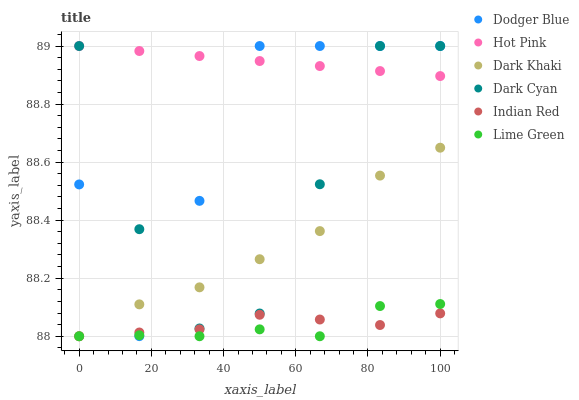Does Lime Green have the minimum area under the curve?
Answer yes or no. Yes. Does Hot Pink have the maximum area under the curve?
Answer yes or no. Yes. Does Dark Khaki have the minimum area under the curve?
Answer yes or no. No. Does Dark Khaki have the maximum area under the curve?
Answer yes or no. No. Is Hot Pink the smoothest?
Answer yes or no. Yes. Is Dodger Blue the roughest?
Answer yes or no. Yes. Is Dark Khaki the smoothest?
Answer yes or no. No. Is Dark Khaki the roughest?
Answer yes or no. No. Does Dark Khaki have the lowest value?
Answer yes or no. Yes. Does Dodger Blue have the lowest value?
Answer yes or no. No. Does Dark Cyan have the highest value?
Answer yes or no. Yes. Does Dark Khaki have the highest value?
Answer yes or no. No. Is Dark Khaki less than Hot Pink?
Answer yes or no. Yes. Is Dark Cyan greater than Lime Green?
Answer yes or no. Yes. Does Dark Khaki intersect Indian Red?
Answer yes or no. Yes. Is Dark Khaki less than Indian Red?
Answer yes or no. No. Is Dark Khaki greater than Indian Red?
Answer yes or no. No. Does Dark Khaki intersect Hot Pink?
Answer yes or no. No. 